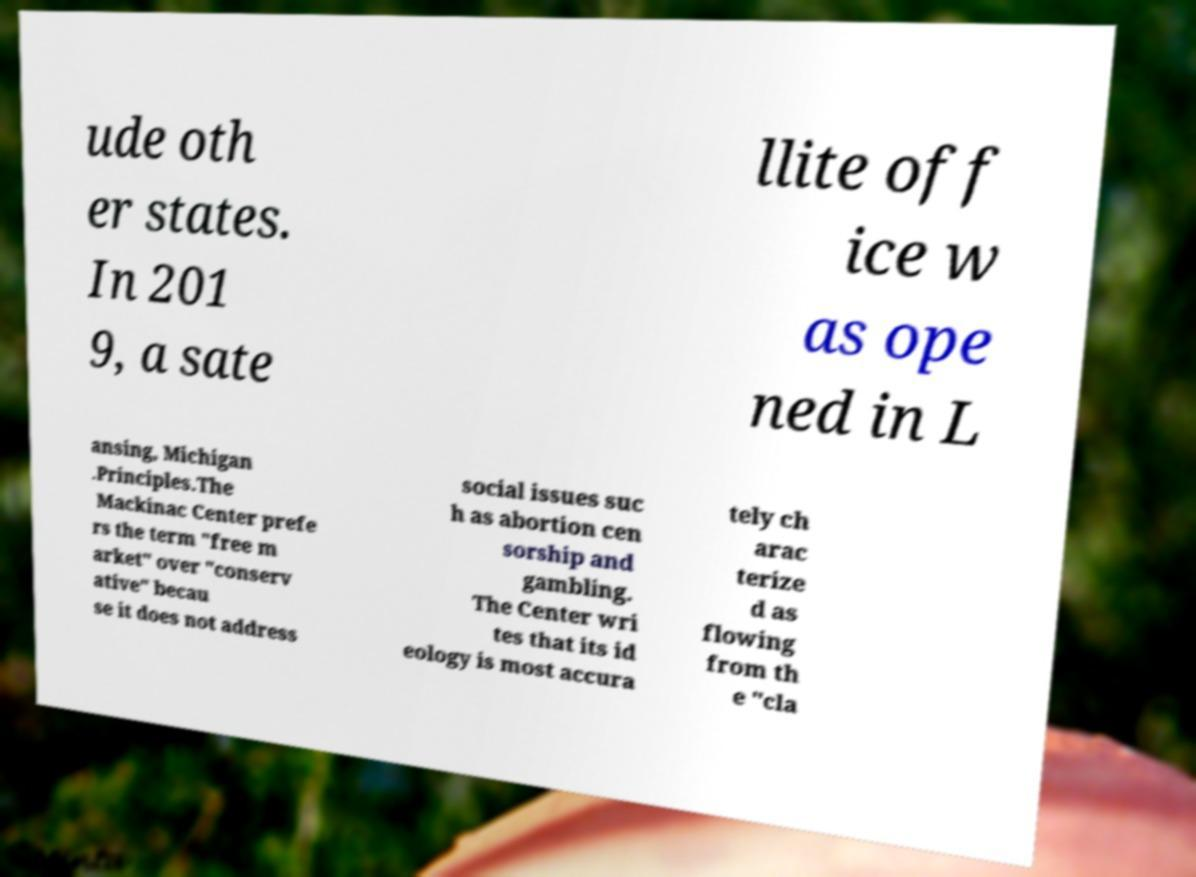There's text embedded in this image that I need extracted. Can you transcribe it verbatim? ude oth er states. In 201 9, a sate llite off ice w as ope ned in L ansing, Michigan .Principles.The Mackinac Center prefe rs the term "free m arket" over "conserv ative" becau se it does not address social issues suc h as abortion cen sorship and gambling. The Center wri tes that its id eology is most accura tely ch arac terize d as flowing from th e "cla 